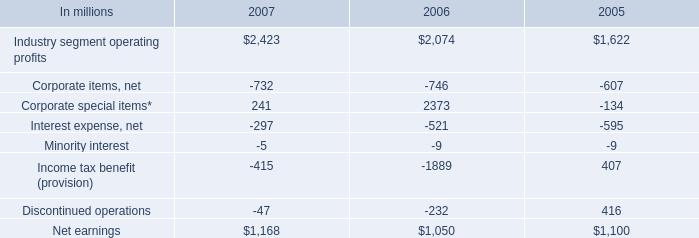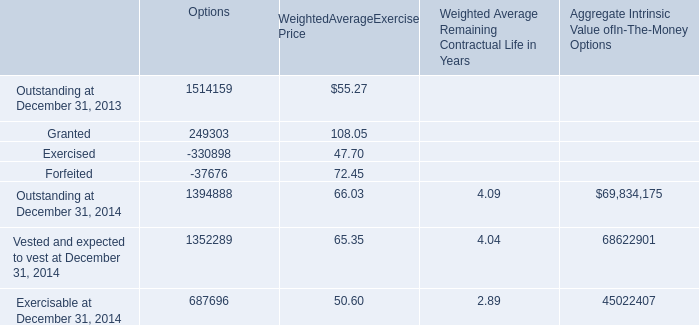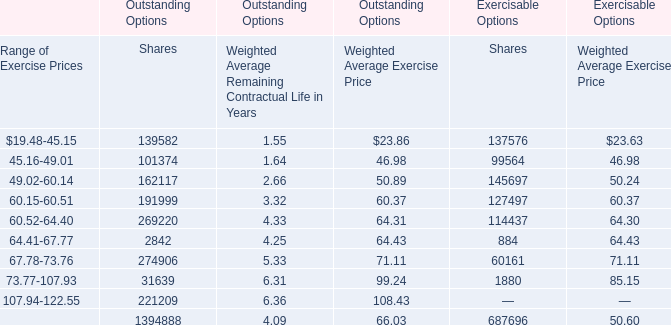How many Weighted AverageExercise Price exceed the average of Weighted AverageExercise Price in 2013? 
Answer: 2. 